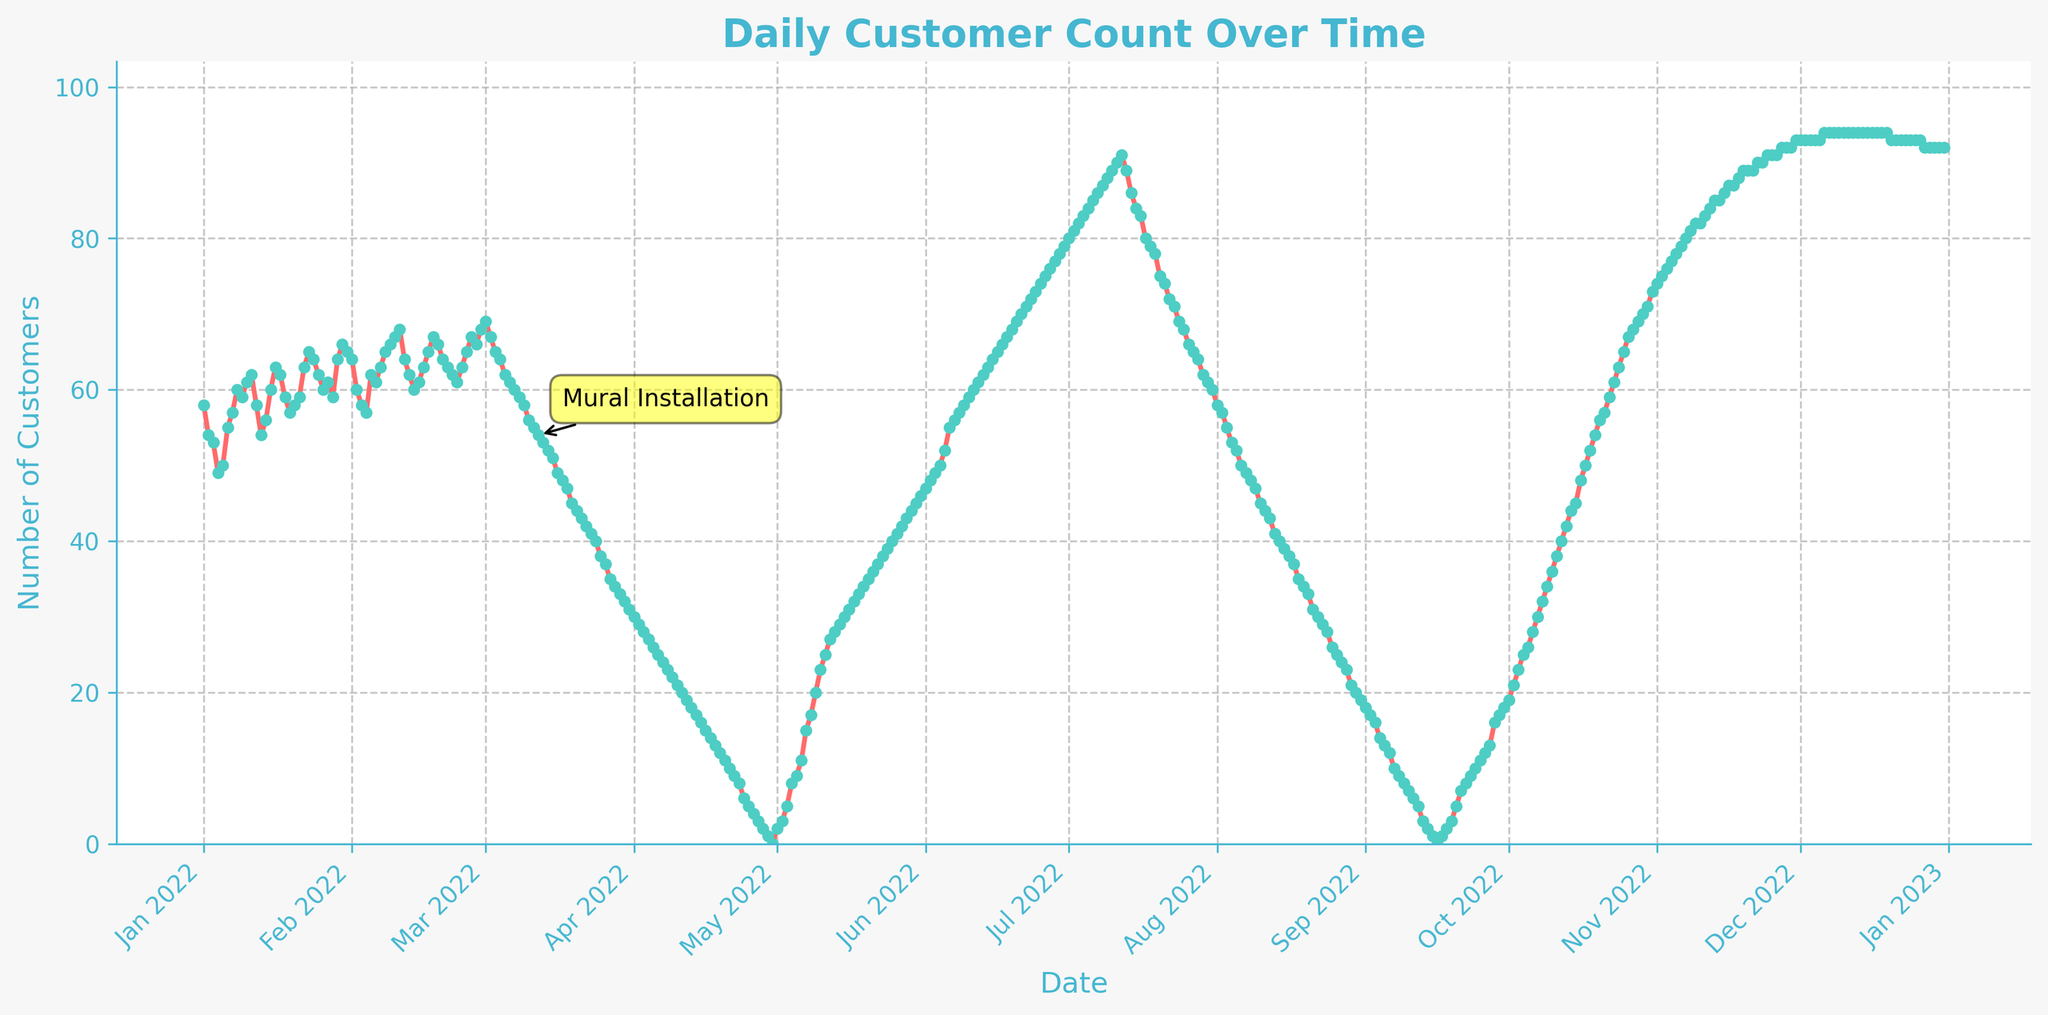What is the title of the plot? The title is usually positioned at the top of the figure and often written in a larger font size. In this figure, the title indicates what the plot is visualizing.
Answer: Daily Customer Count Over Time How many data points are shown in the plot? Each data point in the plot corresponds to one day's customer count, plotted throughout the year. Since there are 365 days in a year, there should be 365 data points.
Answer: 365 What does the x-axis represent? The x-axis usually represents time in a time series plot. In this figure, it shows the dates throughout the year.
Answer: Date What does the y-axis represent? The y-axis usually represents the measured variable in a time series plot. In this figure, it indicates the number of daily customers.
Answer: Number of Customers What is the general trend of the customer count before and after the mural installation? By observing the plot, you can notice the trend over time. The customer count initially declines, and after the mural installation, it starts increasing again. This indicates that the mural might have positively impacted the number of customers.
Answer: Decrease then Increase On which date was the mural installed? The figure contains an annotation that marks the mural installation date. According to the annotation, the mural was installed around the 70th data point which corresponds to early March.
Answer: Early March What is the approximate range of customer count before the mural installation? By observing the trend line before the mural installation annotation, you can estimate the highest and lowest number of customers. The range varies between approximately 30 and 90 customers.
Answer: 30 to 90 What is the general trend of customer count between March and August? By examining the time window from March to August, you can see that the customer count consistently decreases during this period.
Answer: Decrease How does the customer count in October compare to that in January? Observing both months on the x-axis, in January, the number of customers is around 60-70, while in October, it displays an increasing trend, reaching up to about 60-70 again.
Answer: Similar What is the average customer count for April, May, and June? First, identify April, May, June on the x-axis, then locate their corresponding data points on the y-axis. Calculate the average by summing the values and dividing by the number of days in these three months.
Answer: Average for the months 